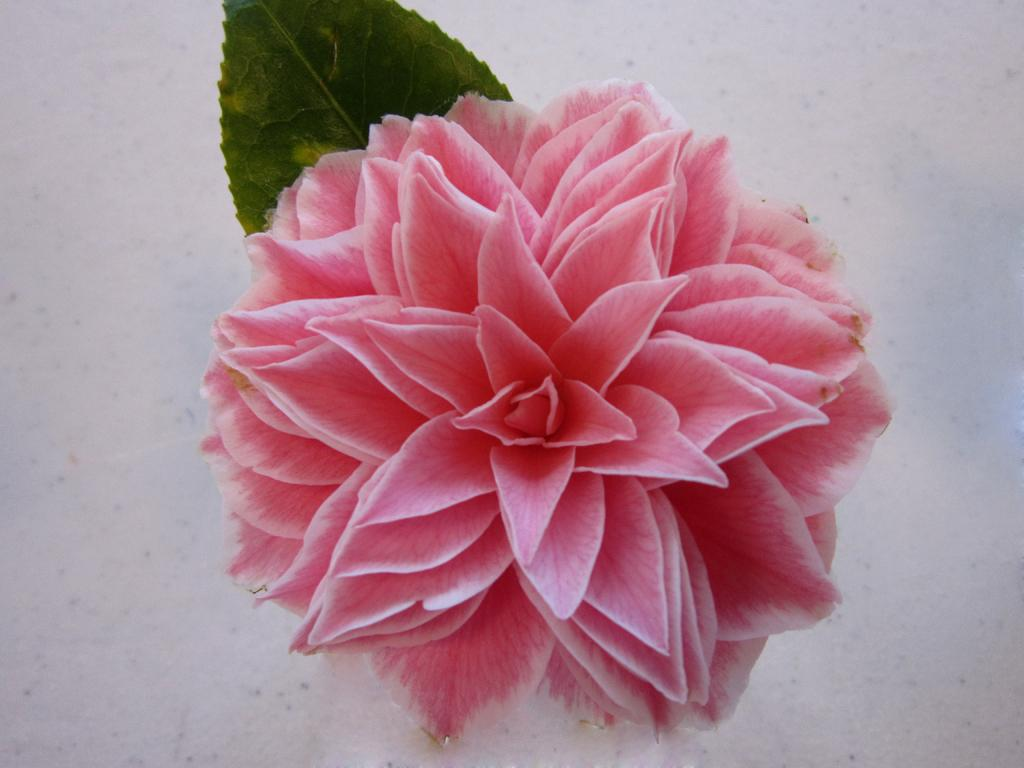What is the main subject in the center of the image? There is a flower in the center of the image. What else can be seen in the background of the image? There is a leaf and a wall in the background of the image. What type of salt can be seen on the petals of the flower in the image? There is no salt present on the flower in the image. 